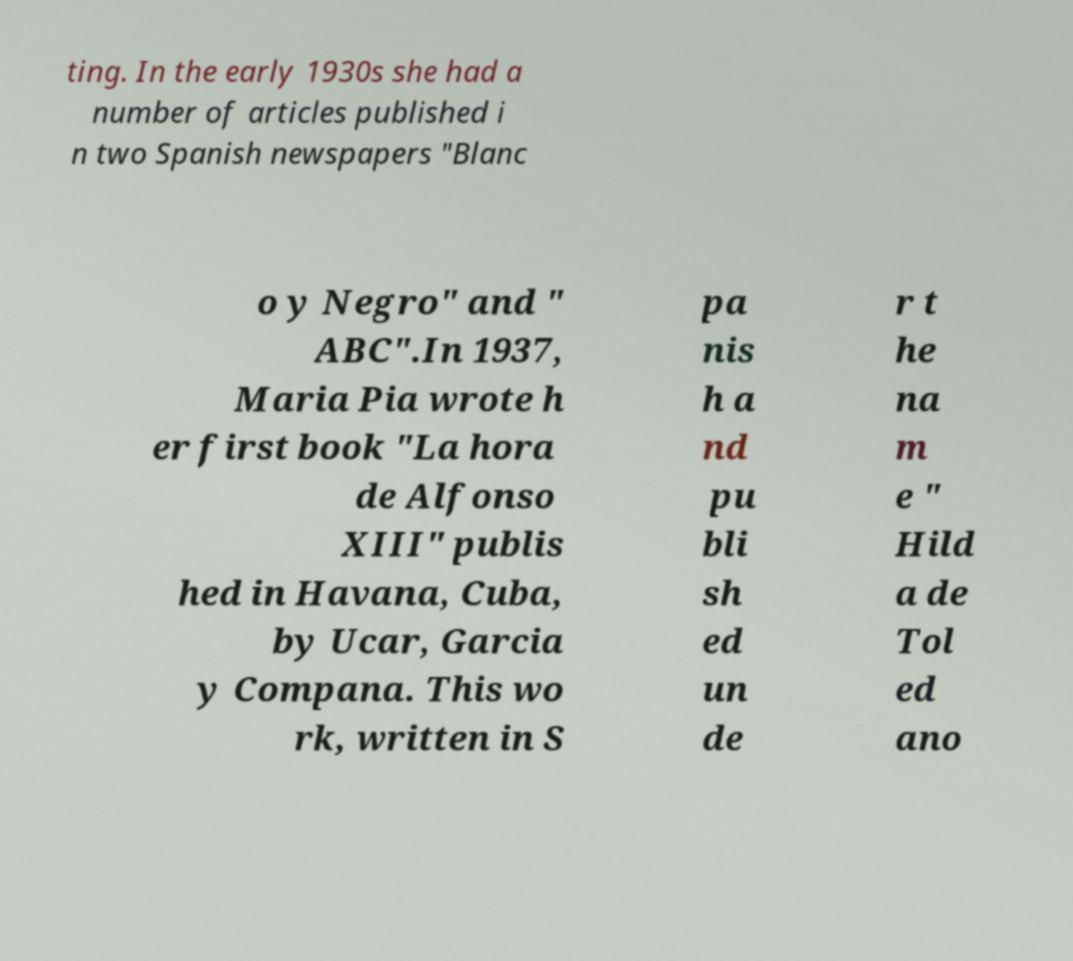Could you assist in decoding the text presented in this image and type it out clearly? ting. In the early 1930s she had a number of articles published i n two Spanish newspapers "Blanc o y Negro" and " ABC".In 1937, Maria Pia wrote h er first book "La hora de Alfonso XIII" publis hed in Havana, Cuba, by Ucar, Garcia y Compana. This wo rk, written in S pa nis h a nd pu bli sh ed un de r t he na m e " Hild a de Tol ed ano 